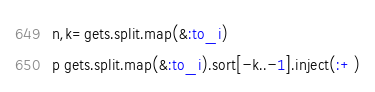Convert code to text. <code><loc_0><loc_0><loc_500><loc_500><_Ruby_>n,k=gets.split.map(&:to_i)
p gets.split.map(&:to_i).sort[-k..-1].inject(:+)</code> 